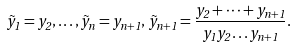Convert formula to latex. <formula><loc_0><loc_0><loc_500><loc_500>\tilde { y } _ { 1 } = y _ { 2 } , \dots , \tilde { y } _ { n } = y _ { n + 1 } , \, \tilde { y } _ { n + 1 } = \frac { y _ { 2 } + \dots + y _ { n + 1 } } { y _ { 1 } y _ { 2 } \dots y _ { n + 1 } } .</formula> 